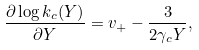<formula> <loc_0><loc_0><loc_500><loc_500>\frac { \partial \log k _ { c } ( Y ) } { \partial Y } = v _ { + } - \frac { 3 } { 2 \gamma _ { c } Y } ,</formula> 